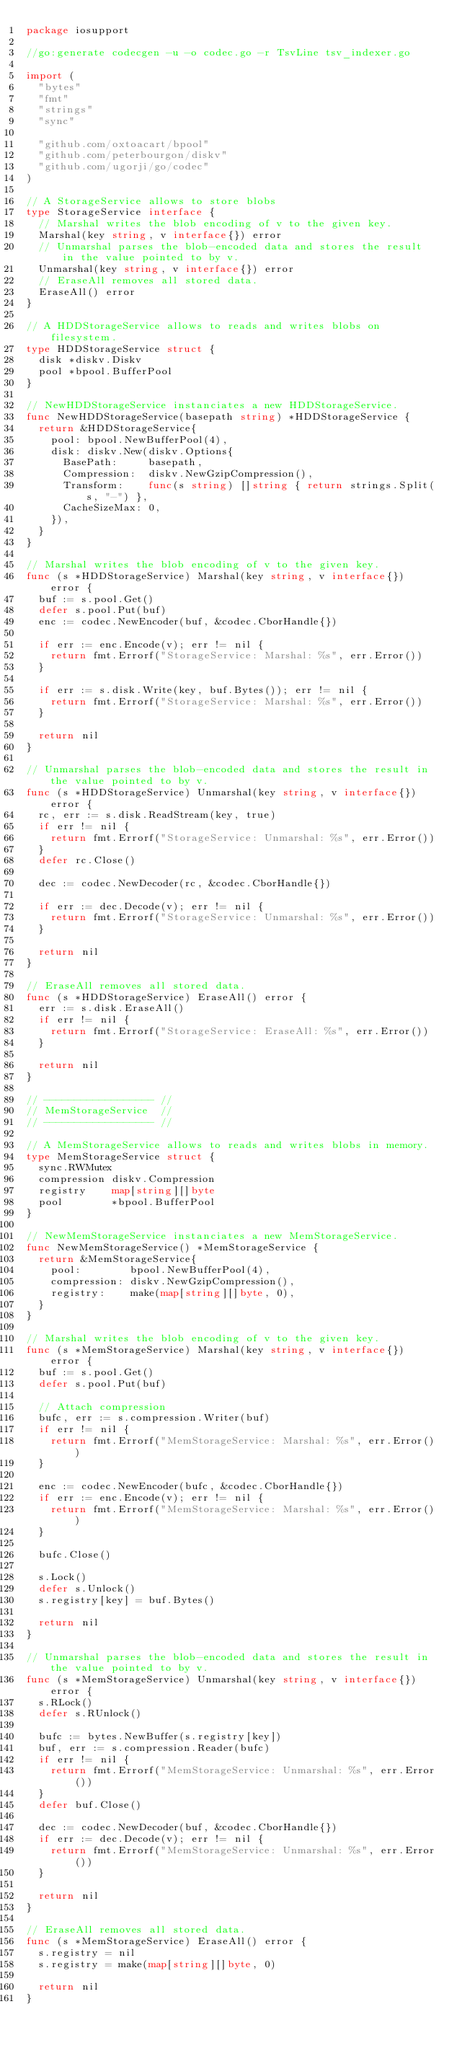<code> <loc_0><loc_0><loc_500><loc_500><_Go_>package iosupport

//go:generate codecgen -u -o codec.go -r TsvLine tsv_indexer.go

import (
	"bytes"
	"fmt"
	"strings"
	"sync"

	"github.com/oxtoacart/bpool"
	"github.com/peterbourgon/diskv"
	"github.com/ugorji/go/codec"
)

// A StorageService allows to store blobs
type StorageService interface {
	// Marshal writes the blob encoding of v to the given key.
	Marshal(key string, v interface{}) error
	// Unmarshal parses the blob-encoded data and stores the result in the value pointed to by v.
	Unmarshal(key string, v interface{}) error
	// EraseAll removes all stored data.
	EraseAll() error
}

// A HDDStorageService allows to reads and writes blobs on filesystem.
type HDDStorageService struct {
	disk *diskv.Diskv
	pool *bpool.BufferPool
}

// NewHDDStorageService instanciates a new HDDStorageService.
func NewHDDStorageService(basepath string) *HDDStorageService {
	return &HDDStorageService{
		pool: bpool.NewBufferPool(4),
		disk: diskv.New(diskv.Options{
			BasePath:     basepath,
			Compression:  diskv.NewGzipCompression(),
			Transform:    func(s string) []string { return strings.Split(s, "-") },
			CacheSizeMax: 0,
		}),
	}
}

// Marshal writes the blob encoding of v to the given key.
func (s *HDDStorageService) Marshal(key string, v interface{}) error {
	buf := s.pool.Get()
	defer s.pool.Put(buf)
	enc := codec.NewEncoder(buf, &codec.CborHandle{})

	if err := enc.Encode(v); err != nil {
		return fmt.Errorf("StorageService: Marshal: %s", err.Error())
	}

	if err := s.disk.Write(key, buf.Bytes()); err != nil {
		return fmt.Errorf("StorageService: Marshal: %s", err.Error())
	}

	return nil
}

// Unmarshal parses the blob-encoded data and stores the result in the value pointed to by v.
func (s *HDDStorageService) Unmarshal(key string, v interface{}) error {
	rc, err := s.disk.ReadStream(key, true)
	if err != nil {
		return fmt.Errorf("StorageService: Unmarshal: %s", err.Error())
	}
	defer rc.Close()

	dec := codec.NewDecoder(rc, &codec.CborHandle{})

	if err := dec.Decode(v); err != nil {
		return fmt.Errorf("StorageService: Unmarshal: %s", err.Error())
	}

	return nil
}

// EraseAll removes all stored data.
func (s *HDDStorageService) EraseAll() error {
	err := s.disk.EraseAll()
	if err != nil {
		return fmt.Errorf("StorageService: EraseAll: %s", err.Error())
	}

	return nil
}

// ------------------ //
// MemStorageService  //
// ------------------ //

// A MemStorageService allows to reads and writes blobs in memory.
type MemStorageService struct {
	sync.RWMutex
	compression diskv.Compression
	registry    map[string][]byte
	pool        *bpool.BufferPool
}

// NewMemStorageService instanciates a new MemStorageService.
func NewMemStorageService() *MemStorageService {
	return &MemStorageService{
		pool:        bpool.NewBufferPool(4),
		compression: diskv.NewGzipCompression(),
		registry:    make(map[string][]byte, 0),
	}
}

// Marshal writes the blob encoding of v to the given key.
func (s *MemStorageService) Marshal(key string, v interface{}) error {
	buf := s.pool.Get()
	defer s.pool.Put(buf)

	// Attach compression
	bufc, err := s.compression.Writer(buf)
	if err != nil {
		return fmt.Errorf("MemStorageService: Marshal: %s", err.Error())
	}

	enc := codec.NewEncoder(bufc, &codec.CborHandle{})
	if err := enc.Encode(v); err != nil {
		return fmt.Errorf("MemStorageService: Marshal: %s", err.Error())
	}

	bufc.Close()

	s.Lock()
	defer s.Unlock()
	s.registry[key] = buf.Bytes()

	return nil
}

// Unmarshal parses the blob-encoded data and stores the result in the value pointed to by v.
func (s *MemStorageService) Unmarshal(key string, v interface{}) error {
	s.RLock()
	defer s.RUnlock()

	bufc := bytes.NewBuffer(s.registry[key])
	buf, err := s.compression.Reader(bufc)
	if err != nil {
		return fmt.Errorf("MemStorageService: Unmarshal: %s", err.Error())
	}
	defer buf.Close()

	dec := codec.NewDecoder(buf, &codec.CborHandle{})
	if err := dec.Decode(v); err != nil {
		return fmt.Errorf("MemStorageService: Unmarshal: %s", err.Error())
	}

	return nil
}

// EraseAll removes all stored data.
func (s *MemStorageService) EraseAll() error {
	s.registry = nil
	s.registry = make(map[string][]byte, 0)

	return nil
}
</code> 